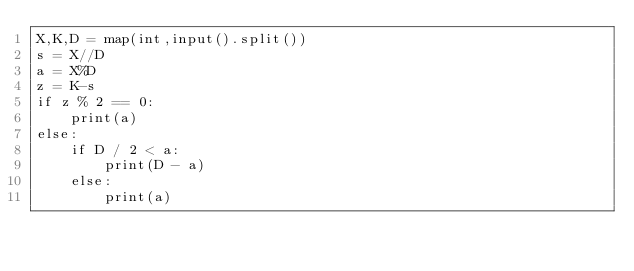<code> <loc_0><loc_0><loc_500><loc_500><_Python_>X,K,D = map(int,input().split())
s = X//D
a = X%D
z = K-s
if z % 2 == 0:
    print(a)
else:
    if D / 2 < a:
        print(D - a)
    else:
        print(a)</code> 